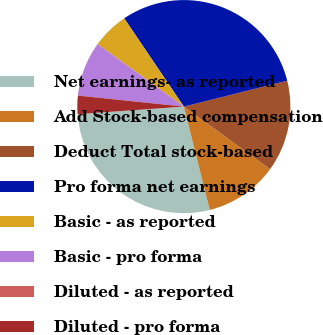<chart> <loc_0><loc_0><loc_500><loc_500><pie_chart><fcel>Net earnings- as reported<fcel>Add Stock-based compensation<fcel>Deduct Total stock-based<fcel>Pro forma net earnings<fcel>Basic - as reported<fcel>Basic - pro forma<fcel>Diluted - as reported<fcel>Diluted - pro forma<nl><fcel>27.78%<fcel>11.11%<fcel>13.89%<fcel>30.56%<fcel>5.56%<fcel>8.33%<fcel>0.0%<fcel>2.78%<nl></chart> 